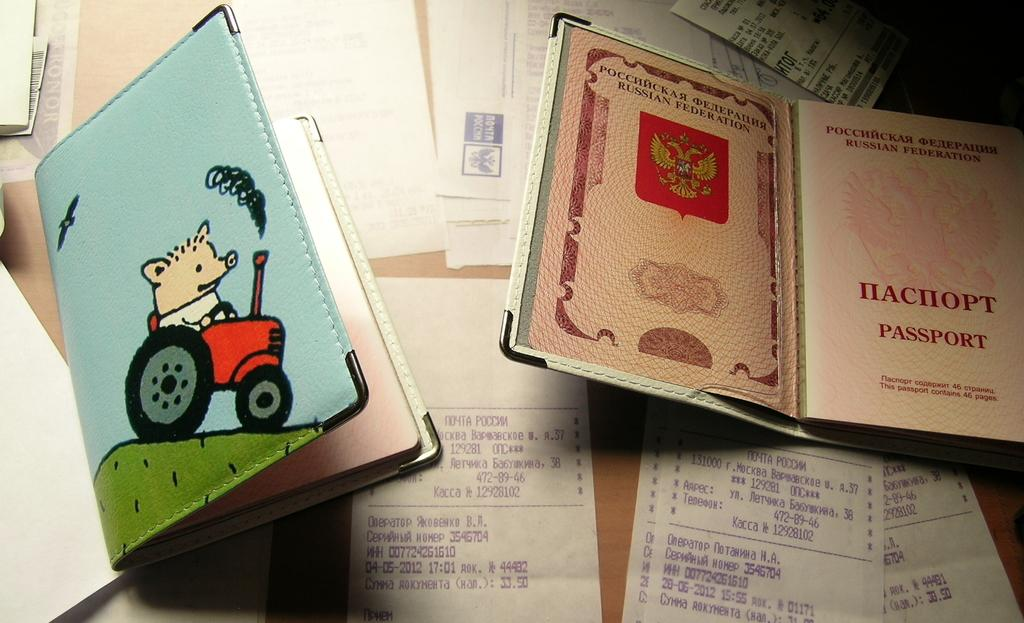<image>
Relay a brief, clear account of the picture shown. the word passport is on the page in the book 